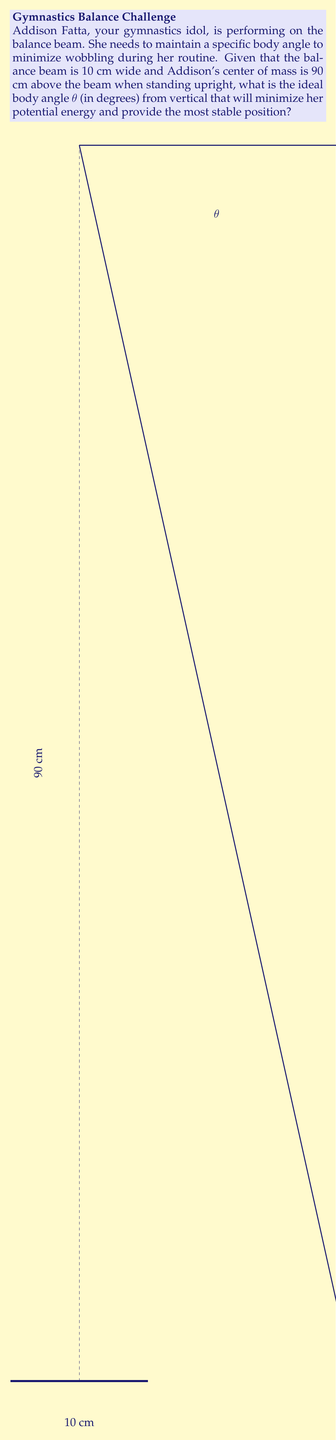What is the answer to this math problem? To solve this problem, we'll use the principle that the most stable position is achieved when the potential energy is minimized. Here's the step-by-step solution:

1) Let's define the variables:
   h = height of center of mass
   x = horizontal displacement of center of mass
   θ = angle from vertical

2) The potential energy (PE) is proportional to the height of the center of mass:
   $PE \propto h$

3) We can express h in terms of θ:
   $h = 90 \cos θ$

4) The horizontal displacement x is:
   $x = 90 \sin θ$

5) For stability, x should not exceed half the beam width:
   $90 \sin θ \leq 5$

6) Solving this inequality:
   $\sin θ \leq \frac{5}{90} = \frac{1}{18}$
   $θ \leq \arcsin(\frac{1}{18})$

7) To find the exact angle, we minimize h:
   $\frac{d}{dθ}(90 \cos θ) = -90 \sin θ = 0$
   $\sin θ = 0$
   $θ = 0$

8) However, θ = 0 means standing perfectly upright, which is not stable. The most stable angle will be the maximum allowed by the beam width constraint.

9) Therefore, the ideal angle is:
   $θ = \arcsin(\frac{1}{18})$

10) Converting to degrees:
    $θ = \arcsin(\frac{1}{18}) \cdot \frac{180}{\pi} \approx 3.18°$
Answer: $3.18°$ 